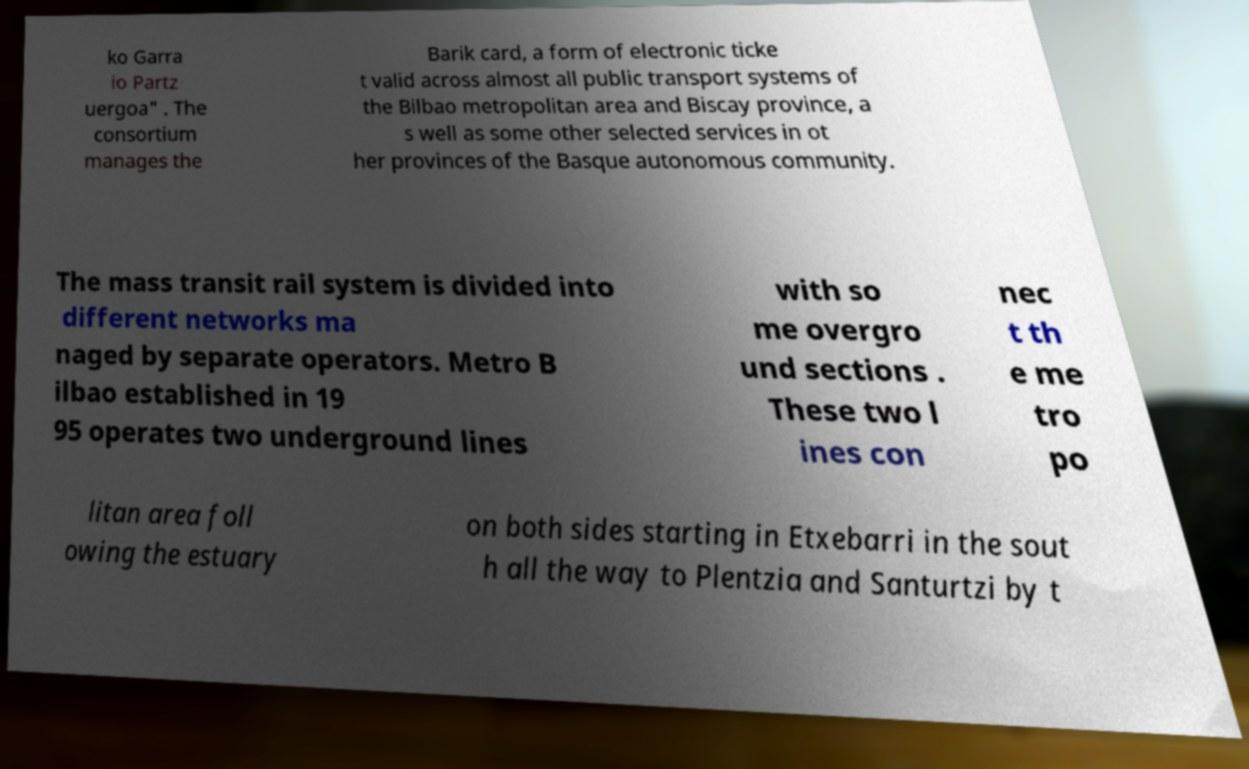Could you assist in decoding the text presented in this image and type it out clearly? ko Garra io Partz uergoa" . The consortium manages the Barik card, a form of electronic ticke t valid across almost all public transport systems of the Bilbao metropolitan area and Biscay province, a s well as some other selected services in ot her provinces of the Basque autonomous community. The mass transit rail system is divided into different networks ma naged by separate operators. Metro B ilbao established in 19 95 operates two underground lines with so me overgro und sections . These two l ines con nec t th e me tro po litan area foll owing the estuary on both sides starting in Etxebarri in the sout h all the way to Plentzia and Santurtzi by t 